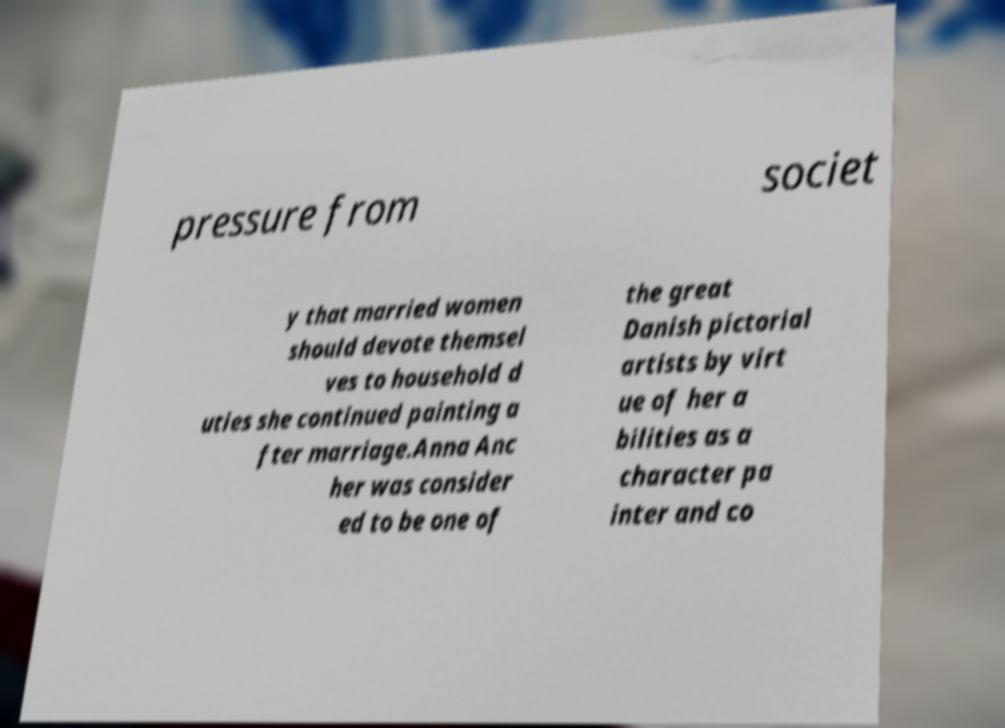Can you read and provide the text displayed in the image?This photo seems to have some interesting text. Can you extract and type it out for me? pressure from societ y that married women should devote themsel ves to household d uties she continued painting a fter marriage.Anna Anc her was consider ed to be one of the great Danish pictorial artists by virt ue of her a bilities as a character pa inter and co 